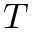Convert formula to latex. <formula><loc_0><loc_0><loc_500><loc_500>T</formula> 